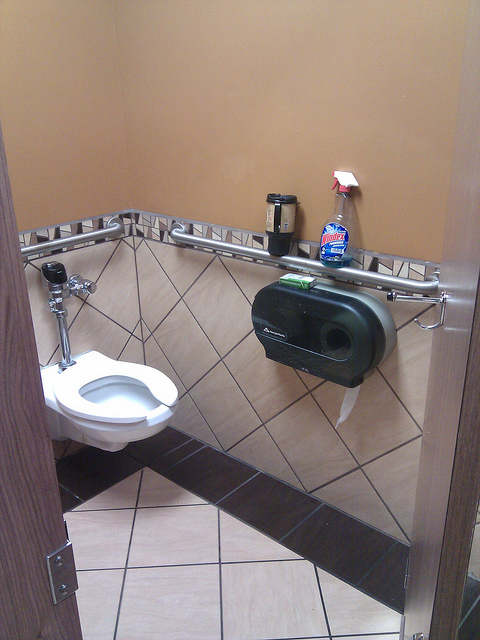<image>The toilet does? It's ambiguous what the toilet does. But it can flush. The toilet does? I don't know what the toilet does. It can flush or it can't. 